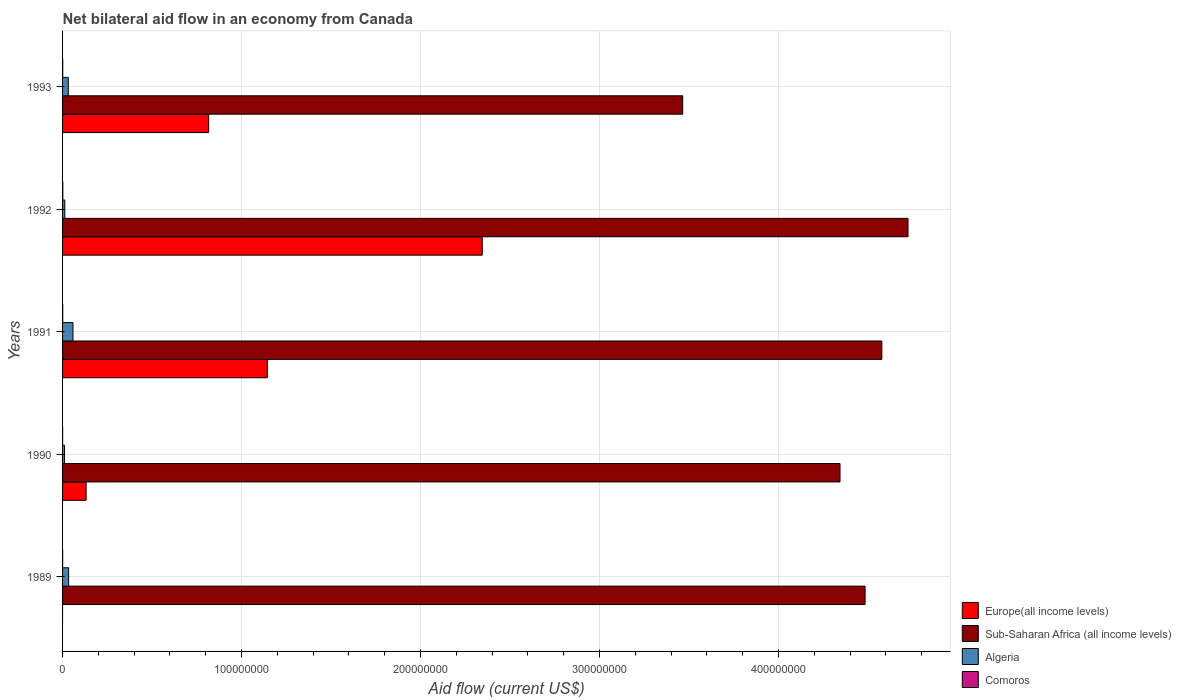How many different coloured bars are there?
Your response must be concise. 4. Are the number of bars per tick equal to the number of legend labels?
Offer a very short reply. No. How many bars are there on the 2nd tick from the bottom?
Make the answer very short. 4. What is the label of the 5th group of bars from the top?
Make the answer very short. 1989. In how many cases, is the number of bars for a given year not equal to the number of legend labels?
Your answer should be compact. 1. What is the net bilateral aid flow in Algeria in 1993?
Offer a very short reply. 3.20e+06. Across all years, what is the minimum net bilateral aid flow in Algeria?
Offer a terse response. 1.09e+06. In which year was the net bilateral aid flow in Algeria maximum?
Keep it short and to the point. 1991. What is the difference between the net bilateral aid flow in Algeria in 1993 and the net bilateral aid flow in Comoros in 1991?
Provide a short and direct response. 3.11e+06. What is the average net bilateral aid flow in Europe(all income levels) per year?
Offer a very short reply. 8.87e+07. In the year 1990, what is the difference between the net bilateral aid flow in Comoros and net bilateral aid flow in Algeria?
Offer a very short reply. -1.06e+06. In how many years, is the net bilateral aid flow in Sub-Saharan Africa (all income levels) greater than 380000000 US$?
Your answer should be very brief. 4. What is the ratio of the net bilateral aid flow in Comoros in 1989 to that in 1992?
Offer a terse response. 0.36. Is the difference between the net bilateral aid flow in Comoros in 1989 and 1992 greater than the difference between the net bilateral aid flow in Algeria in 1989 and 1992?
Offer a terse response. No. What is the difference between the highest and the second highest net bilateral aid flow in Sub-Saharan Africa (all income levels)?
Provide a succinct answer. 1.46e+07. What is the difference between the highest and the lowest net bilateral aid flow in Sub-Saharan Africa (all income levels)?
Provide a short and direct response. 1.26e+08. Is the sum of the net bilateral aid flow in Comoros in 1990 and 1991 greater than the maximum net bilateral aid flow in Algeria across all years?
Keep it short and to the point. No. Is it the case that in every year, the sum of the net bilateral aid flow in Europe(all income levels) and net bilateral aid flow in Algeria is greater than the sum of net bilateral aid flow in Comoros and net bilateral aid flow in Sub-Saharan Africa (all income levels)?
Your answer should be compact. No. Is it the case that in every year, the sum of the net bilateral aid flow in Europe(all income levels) and net bilateral aid flow in Sub-Saharan Africa (all income levels) is greater than the net bilateral aid flow in Comoros?
Provide a succinct answer. Yes. Are all the bars in the graph horizontal?
Provide a succinct answer. Yes. Does the graph contain any zero values?
Provide a short and direct response. Yes. Does the graph contain grids?
Your answer should be very brief. Yes. How many legend labels are there?
Your answer should be very brief. 4. How are the legend labels stacked?
Make the answer very short. Vertical. What is the title of the graph?
Provide a succinct answer. Net bilateral aid flow in an economy from Canada. What is the label or title of the Y-axis?
Your answer should be compact. Years. What is the Aid flow (current US$) in Europe(all income levels) in 1989?
Keep it short and to the point. 0. What is the Aid flow (current US$) in Sub-Saharan Africa (all income levels) in 1989?
Provide a succinct answer. 4.48e+08. What is the Aid flow (current US$) of Algeria in 1989?
Ensure brevity in your answer.  3.39e+06. What is the Aid flow (current US$) of Comoros in 1989?
Offer a very short reply. 5.00e+04. What is the Aid flow (current US$) of Europe(all income levels) in 1990?
Give a very brief answer. 1.32e+07. What is the Aid flow (current US$) of Sub-Saharan Africa (all income levels) in 1990?
Provide a short and direct response. 4.34e+08. What is the Aid flow (current US$) of Algeria in 1990?
Keep it short and to the point. 1.09e+06. What is the Aid flow (current US$) of Comoros in 1990?
Keep it short and to the point. 3.00e+04. What is the Aid flow (current US$) of Europe(all income levels) in 1991?
Your answer should be very brief. 1.14e+08. What is the Aid flow (current US$) of Sub-Saharan Africa (all income levels) in 1991?
Keep it short and to the point. 4.58e+08. What is the Aid flow (current US$) in Algeria in 1991?
Provide a short and direct response. 5.81e+06. What is the Aid flow (current US$) in Europe(all income levels) in 1992?
Provide a short and direct response. 2.34e+08. What is the Aid flow (current US$) of Sub-Saharan Africa (all income levels) in 1992?
Make the answer very short. 4.72e+08. What is the Aid flow (current US$) of Algeria in 1992?
Give a very brief answer. 1.25e+06. What is the Aid flow (current US$) of Comoros in 1992?
Your answer should be very brief. 1.40e+05. What is the Aid flow (current US$) in Europe(all income levels) in 1993?
Ensure brevity in your answer.  8.16e+07. What is the Aid flow (current US$) in Sub-Saharan Africa (all income levels) in 1993?
Make the answer very short. 3.46e+08. What is the Aid flow (current US$) in Algeria in 1993?
Keep it short and to the point. 3.20e+06. Across all years, what is the maximum Aid flow (current US$) in Europe(all income levels)?
Give a very brief answer. 2.34e+08. Across all years, what is the maximum Aid flow (current US$) in Sub-Saharan Africa (all income levels)?
Offer a very short reply. 4.72e+08. Across all years, what is the maximum Aid flow (current US$) in Algeria?
Provide a succinct answer. 5.81e+06. Across all years, what is the maximum Aid flow (current US$) in Comoros?
Offer a terse response. 1.40e+05. Across all years, what is the minimum Aid flow (current US$) of Sub-Saharan Africa (all income levels)?
Provide a short and direct response. 3.46e+08. Across all years, what is the minimum Aid flow (current US$) in Algeria?
Give a very brief answer. 1.09e+06. Across all years, what is the minimum Aid flow (current US$) in Comoros?
Provide a short and direct response. 3.00e+04. What is the total Aid flow (current US$) in Europe(all income levels) in the graph?
Keep it short and to the point. 4.44e+08. What is the total Aid flow (current US$) in Sub-Saharan Africa (all income levels) in the graph?
Ensure brevity in your answer.  2.16e+09. What is the total Aid flow (current US$) of Algeria in the graph?
Offer a terse response. 1.47e+07. What is the difference between the Aid flow (current US$) in Sub-Saharan Africa (all income levels) in 1989 and that in 1990?
Provide a short and direct response. 1.40e+07. What is the difference between the Aid flow (current US$) of Algeria in 1989 and that in 1990?
Your answer should be compact. 2.30e+06. What is the difference between the Aid flow (current US$) of Comoros in 1989 and that in 1990?
Offer a terse response. 2.00e+04. What is the difference between the Aid flow (current US$) of Sub-Saharan Africa (all income levels) in 1989 and that in 1991?
Give a very brief answer. -9.37e+06. What is the difference between the Aid flow (current US$) in Algeria in 1989 and that in 1991?
Provide a succinct answer. -2.42e+06. What is the difference between the Aid flow (current US$) of Comoros in 1989 and that in 1991?
Ensure brevity in your answer.  -4.00e+04. What is the difference between the Aid flow (current US$) in Sub-Saharan Africa (all income levels) in 1989 and that in 1992?
Offer a very short reply. -2.40e+07. What is the difference between the Aid flow (current US$) in Algeria in 1989 and that in 1992?
Offer a very short reply. 2.14e+06. What is the difference between the Aid flow (current US$) of Sub-Saharan Africa (all income levels) in 1989 and that in 1993?
Provide a short and direct response. 1.02e+08. What is the difference between the Aid flow (current US$) of Algeria in 1989 and that in 1993?
Keep it short and to the point. 1.90e+05. What is the difference between the Aid flow (current US$) of Europe(all income levels) in 1990 and that in 1991?
Make the answer very short. -1.01e+08. What is the difference between the Aid flow (current US$) of Sub-Saharan Africa (all income levels) in 1990 and that in 1991?
Make the answer very short. -2.34e+07. What is the difference between the Aid flow (current US$) of Algeria in 1990 and that in 1991?
Your answer should be compact. -4.72e+06. What is the difference between the Aid flow (current US$) of Europe(all income levels) in 1990 and that in 1992?
Offer a very short reply. -2.21e+08. What is the difference between the Aid flow (current US$) of Sub-Saharan Africa (all income levels) in 1990 and that in 1992?
Provide a short and direct response. -3.80e+07. What is the difference between the Aid flow (current US$) of Europe(all income levels) in 1990 and that in 1993?
Make the answer very short. -6.85e+07. What is the difference between the Aid flow (current US$) of Sub-Saharan Africa (all income levels) in 1990 and that in 1993?
Provide a short and direct response. 8.79e+07. What is the difference between the Aid flow (current US$) of Algeria in 1990 and that in 1993?
Your answer should be compact. -2.11e+06. What is the difference between the Aid flow (current US$) of Comoros in 1990 and that in 1993?
Make the answer very short. -6.00e+04. What is the difference between the Aid flow (current US$) of Europe(all income levels) in 1991 and that in 1992?
Ensure brevity in your answer.  -1.20e+08. What is the difference between the Aid flow (current US$) in Sub-Saharan Africa (all income levels) in 1991 and that in 1992?
Offer a very short reply. -1.46e+07. What is the difference between the Aid flow (current US$) of Algeria in 1991 and that in 1992?
Offer a very short reply. 4.56e+06. What is the difference between the Aid flow (current US$) in Comoros in 1991 and that in 1992?
Your answer should be very brief. -5.00e+04. What is the difference between the Aid flow (current US$) of Europe(all income levels) in 1991 and that in 1993?
Make the answer very short. 3.28e+07. What is the difference between the Aid flow (current US$) of Sub-Saharan Africa (all income levels) in 1991 and that in 1993?
Offer a terse response. 1.11e+08. What is the difference between the Aid flow (current US$) of Algeria in 1991 and that in 1993?
Make the answer very short. 2.61e+06. What is the difference between the Aid flow (current US$) in Europe(all income levels) in 1992 and that in 1993?
Your response must be concise. 1.53e+08. What is the difference between the Aid flow (current US$) of Sub-Saharan Africa (all income levels) in 1992 and that in 1993?
Provide a short and direct response. 1.26e+08. What is the difference between the Aid flow (current US$) of Algeria in 1992 and that in 1993?
Your answer should be compact. -1.95e+06. What is the difference between the Aid flow (current US$) in Sub-Saharan Africa (all income levels) in 1989 and the Aid flow (current US$) in Algeria in 1990?
Offer a very short reply. 4.47e+08. What is the difference between the Aid flow (current US$) in Sub-Saharan Africa (all income levels) in 1989 and the Aid flow (current US$) in Comoros in 1990?
Ensure brevity in your answer.  4.48e+08. What is the difference between the Aid flow (current US$) in Algeria in 1989 and the Aid flow (current US$) in Comoros in 1990?
Offer a terse response. 3.36e+06. What is the difference between the Aid flow (current US$) of Sub-Saharan Africa (all income levels) in 1989 and the Aid flow (current US$) of Algeria in 1991?
Give a very brief answer. 4.43e+08. What is the difference between the Aid flow (current US$) of Sub-Saharan Africa (all income levels) in 1989 and the Aid flow (current US$) of Comoros in 1991?
Make the answer very short. 4.48e+08. What is the difference between the Aid flow (current US$) in Algeria in 1989 and the Aid flow (current US$) in Comoros in 1991?
Make the answer very short. 3.30e+06. What is the difference between the Aid flow (current US$) in Sub-Saharan Africa (all income levels) in 1989 and the Aid flow (current US$) in Algeria in 1992?
Offer a terse response. 4.47e+08. What is the difference between the Aid flow (current US$) of Sub-Saharan Africa (all income levels) in 1989 and the Aid flow (current US$) of Comoros in 1992?
Your answer should be very brief. 4.48e+08. What is the difference between the Aid flow (current US$) in Algeria in 1989 and the Aid flow (current US$) in Comoros in 1992?
Offer a very short reply. 3.25e+06. What is the difference between the Aid flow (current US$) of Sub-Saharan Africa (all income levels) in 1989 and the Aid flow (current US$) of Algeria in 1993?
Provide a short and direct response. 4.45e+08. What is the difference between the Aid flow (current US$) in Sub-Saharan Africa (all income levels) in 1989 and the Aid flow (current US$) in Comoros in 1993?
Your answer should be compact. 4.48e+08. What is the difference between the Aid flow (current US$) of Algeria in 1989 and the Aid flow (current US$) of Comoros in 1993?
Keep it short and to the point. 3.30e+06. What is the difference between the Aid flow (current US$) of Europe(all income levels) in 1990 and the Aid flow (current US$) of Sub-Saharan Africa (all income levels) in 1991?
Provide a succinct answer. -4.45e+08. What is the difference between the Aid flow (current US$) of Europe(all income levels) in 1990 and the Aid flow (current US$) of Algeria in 1991?
Keep it short and to the point. 7.35e+06. What is the difference between the Aid flow (current US$) of Europe(all income levels) in 1990 and the Aid flow (current US$) of Comoros in 1991?
Offer a very short reply. 1.31e+07. What is the difference between the Aid flow (current US$) of Sub-Saharan Africa (all income levels) in 1990 and the Aid flow (current US$) of Algeria in 1991?
Make the answer very short. 4.29e+08. What is the difference between the Aid flow (current US$) of Sub-Saharan Africa (all income levels) in 1990 and the Aid flow (current US$) of Comoros in 1991?
Ensure brevity in your answer.  4.34e+08. What is the difference between the Aid flow (current US$) in Algeria in 1990 and the Aid flow (current US$) in Comoros in 1991?
Your answer should be very brief. 1.00e+06. What is the difference between the Aid flow (current US$) in Europe(all income levels) in 1990 and the Aid flow (current US$) in Sub-Saharan Africa (all income levels) in 1992?
Offer a terse response. -4.59e+08. What is the difference between the Aid flow (current US$) of Europe(all income levels) in 1990 and the Aid flow (current US$) of Algeria in 1992?
Offer a very short reply. 1.19e+07. What is the difference between the Aid flow (current US$) in Europe(all income levels) in 1990 and the Aid flow (current US$) in Comoros in 1992?
Keep it short and to the point. 1.30e+07. What is the difference between the Aid flow (current US$) of Sub-Saharan Africa (all income levels) in 1990 and the Aid flow (current US$) of Algeria in 1992?
Give a very brief answer. 4.33e+08. What is the difference between the Aid flow (current US$) of Sub-Saharan Africa (all income levels) in 1990 and the Aid flow (current US$) of Comoros in 1992?
Your answer should be compact. 4.34e+08. What is the difference between the Aid flow (current US$) in Algeria in 1990 and the Aid flow (current US$) in Comoros in 1992?
Make the answer very short. 9.50e+05. What is the difference between the Aid flow (current US$) in Europe(all income levels) in 1990 and the Aid flow (current US$) in Sub-Saharan Africa (all income levels) in 1993?
Give a very brief answer. -3.33e+08. What is the difference between the Aid flow (current US$) of Europe(all income levels) in 1990 and the Aid flow (current US$) of Algeria in 1993?
Keep it short and to the point. 9.96e+06. What is the difference between the Aid flow (current US$) in Europe(all income levels) in 1990 and the Aid flow (current US$) in Comoros in 1993?
Your response must be concise. 1.31e+07. What is the difference between the Aid flow (current US$) of Sub-Saharan Africa (all income levels) in 1990 and the Aid flow (current US$) of Algeria in 1993?
Provide a succinct answer. 4.31e+08. What is the difference between the Aid flow (current US$) in Sub-Saharan Africa (all income levels) in 1990 and the Aid flow (current US$) in Comoros in 1993?
Your response must be concise. 4.34e+08. What is the difference between the Aid flow (current US$) of Europe(all income levels) in 1991 and the Aid flow (current US$) of Sub-Saharan Africa (all income levels) in 1992?
Make the answer very short. -3.58e+08. What is the difference between the Aid flow (current US$) of Europe(all income levels) in 1991 and the Aid flow (current US$) of Algeria in 1992?
Keep it short and to the point. 1.13e+08. What is the difference between the Aid flow (current US$) of Europe(all income levels) in 1991 and the Aid flow (current US$) of Comoros in 1992?
Give a very brief answer. 1.14e+08. What is the difference between the Aid flow (current US$) in Sub-Saharan Africa (all income levels) in 1991 and the Aid flow (current US$) in Algeria in 1992?
Provide a short and direct response. 4.56e+08. What is the difference between the Aid flow (current US$) in Sub-Saharan Africa (all income levels) in 1991 and the Aid flow (current US$) in Comoros in 1992?
Provide a short and direct response. 4.58e+08. What is the difference between the Aid flow (current US$) in Algeria in 1991 and the Aid flow (current US$) in Comoros in 1992?
Offer a very short reply. 5.67e+06. What is the difference between the Aid flow (current US$) in Europe(all income levels) in 1991 and the Aid flow (current US$) in Sub-Saharan Africa (all income levels) in 1993?
Give a very brief answer. -2.32e+08. What is the difference between the Aid flow (current US$) in Europe(all income levels) in 1991 and the Aid flow (current US$) in Algeria in 1993?
Ensure brevity in your answer.  1.11e+08. What is the difference between the Aid flow (current US$) in Europe(all income levels) in 1991 and the Aid flow (current US$) in Comoros in 1993?
Give a very brief answer. 1.14e+08. What is the difference between the Aid flow (current US$) in Sub-Saharan Africa (all income levels) in 1991 and the Aid flow (current US$) in Algeria in 1993?
Offer a terse response. 4.55e+08. What is the difference between the Aid flow (current US$) of Sub-Saharan Africa (all income levels) in 1991 and the Aid flow (current US$) of Comoros in 1993?
Offer a terse response. 4.58e+08. What is the difference between the Aid flow (current US$) of Algeria in 1991 and the Aid flow (current US$) of Comoros in 1993?
Provide a short and direct response. 5.72e+06. What is the difference between the Aid flow (current US$) in Europe(all income levels) in 1992 and the Aid flow (current US$) in Sub-Saharan Africa (all income levels) in 1993?
Offer a very short reply. -1.12e+08. What is the difference between the Aid flow (current US$) in Europe(all income levels) in 1992 and the Aid flow (current US$) in Algeria in 1993?
Provide a short and direct response. 2.31e+08. What is the difference between the Aid flow (current US$) in Europe(all income levels) in 1992 and the Aid flow (current US$) in Comoros in 1993?
Provide a short and direct response. 2.34e+08. What is the difference between the Aid flow (current US$) of Sub-Saharan Africa (all income levels) in 1992 and the Aid flow (current US$) of Algeria in 1993?
Make the answer very short. 4.69e+08. What is the difference between the Aid flow (current US$) of Sub-Saharan Africa (all income levels) in 1992 and the Aid flow (current US$) of Comoros in 1993?
Your answer should be very brief. 4.72e+08. What is the difference between the Aid flow (current US$) in Algeria in 1992 and the Aid flow (current US$) in Comoros in 1993?
Give a very brief answer. 1.16e+06. What is the average Aid flow (current US$) in Europe(all income levels) per year?
Provide a short and direct response. 8.87e+07. What is the average Aid flow (current US$) of Sub-Saharan Africa (all income levels) per year?
Your response must be concise. 4.32e+08. What is the average Aid flow (current US$) in Algeria per year?
Offer a terse response. 2.95e+06. What is the average Aid flow (current US$) in Comoros per year?
Make the answer very short. 8.00e+04. In the year 1989, what is the difference between the Aid flow (current US$) of Sub-Saharan Africa (all income levels) and Aid flow (current US$) of Algeria?
Your response must be concise. 4.45e+08. In the year 1989, what is the difference between the Aid flow (current US$) in Sub-Saharan Africa (all income levels) and Aid flow (current US$) in Comoros?
Your response must be concise. 4.48e+08. In the year 1989, what is the difference between the Aid flow (current US$) in Algeria and Aid flow (current US$) in Comoros?
Give a very brief answer. 3.34e+06. In the year 1990, what is the difference between the Aid flow (current US$) in Europe(all income levels) and Aid flow (current US$) in Sub-Saharan Africa (all income levels)?
Your answer should be very brief. -4.21e+08. In the year 1990, what is the difference between the Aid flow (current US$) of Europe(all income levels) and Aid flow (current US$) of Algeria?
Offer a terse response. 1.21e+07. In the year 1990, what is the difference between the Aid flow (current US$) of Europe(all income levels) and Aid flow (current US$) of Comoros?
Your answer should be compact. 1.31e+07. In the year 1990, what is the difference between the Aid flow (current US$) of Sub-Saharan Africa (all income levels) and Aid flow (current US$) of Algeria?
Your response must be concise. 4.33e+08. In the year 1990, what is the difference between the Aid flow (current US$) of Sub-Saharan Africa (all income levels) and Aid flow (current US$) of Comoros?
Provide a short and direct response. 4.34e+08. In the year 1990, what is the difference between the Aid flow (current US$) of Algeria and Aid flow (current US$) of Comoros?
Offer a very short reply. 1.06e+06. In the year 1991, what is the difference between the Aid flow (current US$) in Europe(all income levels) and Aid flow (current US$) in Sub-Saharan Africa (all income levels)?
Your answer should be very brief. -3.43e+08. In the year 1991, what is the difference between the Aid flow (current US$) in Europe(all income levels) and Aid flow (current US$) in Algeria?
Keep it short and to the point. 1.09e+08. In the year 1991, what is the difference between the Aid flow (current US$) in Europe(all income levels) and Aid flow (current US$) in Comoros?
Provide a succinct answer. 1.14e+08. In the year 1991, what is the difference between the Aid flow (current US$) in Sub-Saharan Africa (all income levels) and Aid flow (current US$) in Algeria?
Provide a short and direct response. 4.52e+08. In the year 1991, what is the difference between the Aid flow (current US$) in Sub-Saharan Africa (all income levels) and Aid flow (current US$) in Comoros?
Ensure brevity in your answer.  4.58e+08. In the year 1991, what is the difference between the Aid flow (current US$) of Algeria and Aid flow (current US$) of Comoros?
Your response must be concise. 5.72e+06. In the year 1992, what is the difference between the Aid flow (current US$) in Europe(all income levels) and Aid flow (current US$) in Sub-Saharan Africa (all income levels)?
Make the answer very short. -2.38e+08. In the year 1992, what is the difference between the Aid flow (current US$) in Europe(all income levels) and Aid flow (current US$) in Algeria?
Provide a short and direct response. 2.33e+08. In the year 1992, what is the difference between the Aid flow (current US$) in Europe(all income levels) and Aid flow (current US$) in Comoros?
Your answer should be very brief. 2.34e+08. In the year 1992, what is the difference between the Aid flow (current US$) of Sub-Saharan Africa (all income levels) and Aid flow (current US$) of Algeria?
Give a very brief answer. 4.71e+08. In the year 1992, what is the difference between the Aid flow (current US$) in Sub-Saharan Africa (all income levels) and Aid flow (current US$) in Comoros?
Give a very brief answer. 4.72e+08. In the year 1992, what is the difference between the Aid flow (current US$) in Algeria and Aid flow (current US$) in Comoros?
Your answer should be compact. 1.11e+06. In the year 1993, what is the difference between the Aid flow (current US$) in Europe(all income levels) and Aid flow (current US$) in Sub-Saharan Africa (all income levels)?
Give a very brief answer. -2.65e+08. In the year 1993, what is the difference between the Aid flow (current US$) of Europe(all income levels) and Aid flow (current US$) of Algeria?
Keep it short and to the point. 7.84e+07. In the year 1993, what is the difference between the Aid flow (current US$) of Europe(all income levels) and Aid flow (current US$) of Comoros?
Your response must be concise. 8.15e+07. In the year 1993, what is the difference between the Aid flow (current US$) in Sub-Saharan Africa (all income levels) and Aid flow (current US$) in Algeria?
Offer a very short reply. 3.43e+08. In the year 1993, what is the difference between the Aid flow (current US$) in Sub-Saharan Africa (all income levels) and Aid flow (current US$) in Comoros?
Provide a succinct answer. 3.46e+08. In the year 1993, what is the difference between the Aid flow (current US$) in Algeria and Aid flow (current US$) in Comoros?
Offer a very short reply. 3.11e+06. What is the ratio of the Aid flow (current US$) in Sub-Saharan Africa (all income levels) in 1989 to that in 1990?
Make the answer very short. 1.03. What is the ratio of the Aid flow (current US$) in Algeria in 1989 to that in 1990?
Offer a very short reply. 3.11. What is the ratio of the Aid flow (current US$) of Comoros in 1989 to that in 1990?
Your answer should be very brief. 1.67. What is the ratio of the Aid flow (current US$) of Sub-Saharan Africa (all income levels) in 1989 to that in 1991?
Offer a very short reply. 0.98. What is the ratio of the Aid flow (current US$) in Algeria in 1989 to that in 1991?
Your answer should be very brief. 0.58. What is the ratio of the Aid flow (current US$) in Comoros in 1989 to that in 1991?
Your answer should be compact. 0.56. What is the ratio of the Aid flow (current US$) in Sub-Saharan Africa (all income levels) in 1989 to that in 1992?
Your response must be concise. 0.95. What is the ratio of the Aid flow (current US$) in Algeria in 1989 to that in 1992?
Give a very brief answer. 2.71. What is the ratio of the Aid flow (current US$) in Comoros in 1989 to that in 1992?
Give a very brief answer. 0.36. What is the ratio of the Aid flow (current US$) in Sub-Saharan Africa (all income levels) in 1989 to that in 1993?
Offer a terse response. 1.29. What is the ratio of the Aid flow (current US$) of Algeria in 1989 to that in 1993?
Ensure brevity in your answer.  1.06. What is the ratio of the Aid flow (current US$) in Comoros in 1989 to that in 1993?
Provide a succinct answer. 0.56. What is the ratio of the Aid flow (current US$) of Europe(all income levels) in 1990 to that in 1991?
Your answer should be very brief. 0.12. What is the ratio of the Aid flow (current US$) in Sub-Saharan Africa (all income levels) in 1990 to that in 1991?
Provide a succinct answer. 0.95. What is the ratio of the Aid flow (current US$) in Algeria in 1990 to that in 1991?
Give a very brief answer. 0.19. What is the ratio of the Aid flow (current US$) of Comoros in 1990 to that in 1991?
Your answer should be very brief. 0.33. What is the ratio of the Aid flow (current US$) of Europe(all income levels) in 1990 to that in 1992?
Provide a succinct answer. 0.06. What is the ratio of the Aid flow (current US$) of Sub-Saharan Africa (all income levels) in 1990 to that in 1992?
Ensure brevity in your answer.  0.92. What is the ratio of the Aid flow (current US$) in Algeria in 1990 to that in 1992?
Offer a terse response. 0.87. What is the ratio of the Aid flow (current US$) of Comoros in 1990 to that in 1992?
Ensure brevity in your answer.  0.21. What is the ratio of the Aid flow (current US$) of Europe(all income levels) in 1990 to that in 1993?
Provide a short and direct response. 0.16. What is the ratio of the Aid flow (current US$) in Sub-Saharan Africa (all income levels) in 1990 to that in 1993?
Your answer should be compact. 1.25. What is the ratio of the Aid flow (current US$) of Algeria in 1990 to that in 1993?
Provide a short and direct response. 0.34. What is the ratio of the Aid flow (current US$) of Comoros in 1990 to that in 1993?
Your response must be concise. 0.33. What is the ratio of the Aid flow (current US$) of Europe(all income levels) in 1991 to that in 1992?
Make the answer very short. 0.49. What is the ratio of the Aid flow (current US$) of Sub-Saharan Africa (all income levels) in 1991 to that in 1992?
Make the answer very short. 0.97. What is the ratio of the Aid flow (current US$) in Algeria in 1991 to that in 1992?
Make the answer very short. 4.65. What is the ratio of the Aid flow (current US$) in Comoros in 1991 to that in 1992?
Your answer should be compact. 0.64. What is the ratio of the Aid flow (current US$) of Europe(all income levels) in 1991 to that in 1993?
Provide a short and direct response. 1.4. What is the ratio of the Aid flow (current US$) in Sub-Saharan Africa (all income levels) in 1991 to that in 1993?
Offer a very short reply. 1.32. What is the ratio of the Aid flow (current US$) of Algeria in 1991 to that in 1993?
Ensure brevity in your answer.  1.82. What is the ratio of the Aid flow (current US$) of Comoros in 1991 to that in 1993?
Give a very brief answer. 1. What is the ratio of the Aid flow (current US$) in Europe(all income levels) in 1992 to that in 1993?
Your response must be concise. 2.87. What is the ratio of the Aid flow (current US$) in Sub-Saharan Africa (all income levels) in 1992 to that in 1993?
Your response must be concise. 1.36. What is the ratio of the Aid flow (current US$) of Algeria in 1992 to that in 1993?
Offer a terse response. 0.39. What is the ratio of the Aid flow (current US$) of Comoros in 1992 to that in 1993?
Your response must be concise. 1.56. What is the difference between the highest and the second highest Aid flow (current US$) of Europe(all income levels)?
Offer a terse response. 1.20e+08. What is the difference between the highest and the second highest Aid flow (current US$) of Sub-Saharan Africa (all income levels)?
Your response must be concise. 1.46e+07. What is the difference between the highest and the second highest Aid flow (current US$) of Algeria?
Provide a short and direct response. 2.42e+06. What is the difference between the highest and the lowest Aid flow (current US$) in Europe(all income levels)?
Give a very brief answer. 2.34e+08. What is the difference between the highest and the lowest Aid flow (current US$) in Sub-Saharan Africa (all income levels)?
Your answer should be compact. 1.26e+08. What is the difference between the highest and the lowest Aid flow (current US$) of Algeria?
Provide a succinct answer. 4.72e+06. 